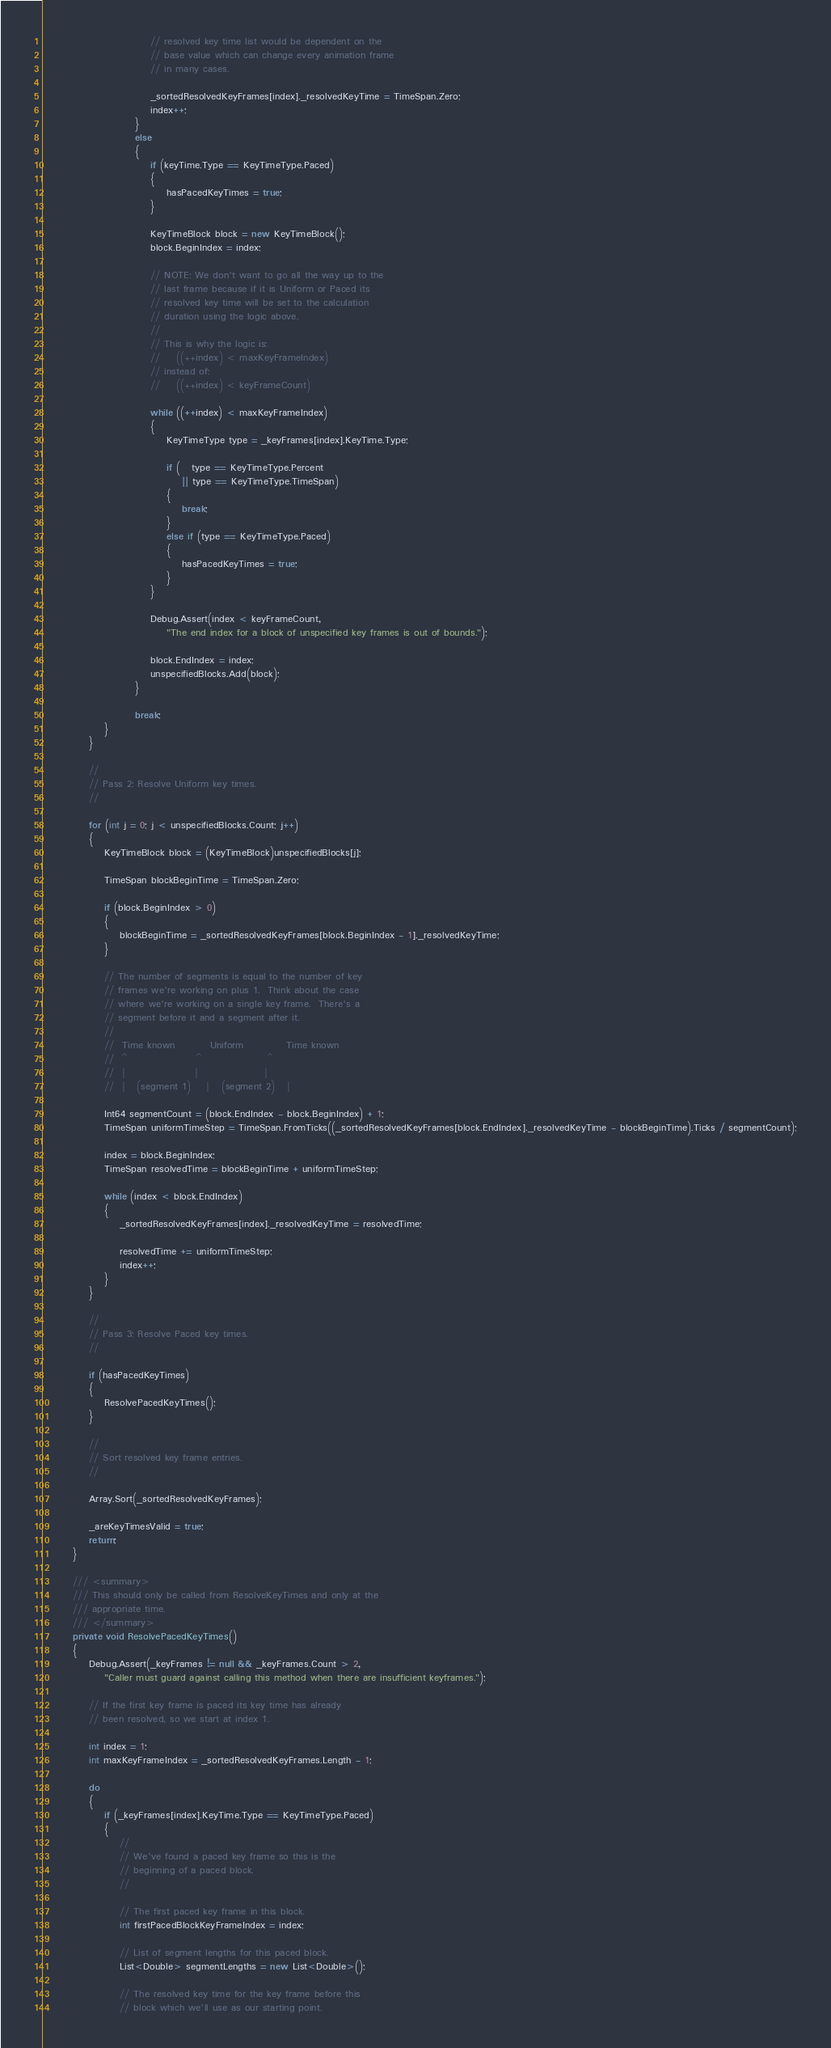Convert code to text. <code><loc_0><loc_0><loc_500><loc_500><_C#_>                            // resolved key time list would be dependent on the
                            // base value which can change every animation frame
                            // in many cases.

                            _sortedResolvedKeyFrames[index]._resolvedKeyTime = TimeSpan.Zero;
                            index++;
                        }
                        else
                        {
                            if (keyTime.Type == KeyTimeType.Paced)
                            {
                                hasPacedKeyTimes = true;
                            }

                            KeyTimeBlock block = new KeyTimeBlock();
                            block.BeginIndex = index;

                            // NOTE: We don't want to go all the way up to the
                            // last frame because if it is Uniform or Paced its
                            // resolved key time will be set to the calculation 
                            // duration using the logic above.
                            //
                            // This is why the logic is:
                            //    ((++index) < maxKeyFrameIndex)
                            // instead of:
                            //    ((++index) < keyFrameCount)

                            while ((++index) < maxKeyFrameIndex)
                            {
                                KeyTimeType type = _keyFrames[index].KeyTime.Type;

                                if (   type == KeyTimeType.Percent
                                    || type == KeyTimeType.TimeSpan)
                                {
                                    break;
                                }   
                                else if (type == KeyTimeType.Paced)
                                {
                                    hasPacedKeyTimes = true;
                                }                                
                            }

                            Debug.Assert(index < keyFrameCount, 
                                "The end index for a block of unspecified key frames is out of bounds.");

                            block.EndIndex = index;
                            unspecifiedBlocks.Add(block);
                        }

                        break;
                }
            }

            //
            // Pass 2: Resolve Uniform key times.
            //

            for (int j = 0; j < unspecifiedBlocks.Count; j++)
            {
                KeyTimeBlock block = (KeyTimeBlock)unspecifiedBlocks[j];

                TimeSpan blockBeginTime = TimeSpan.Zero;

                if (block.BeginIndex > 0)
                {
                    blockBeginTime = _sortedResolvedKeyFrames[block.BeginIndex - 1]._resolvedKeyTime;
                }

                // The number of segments is equal to the number of key
                // frames we're working on plus 1.  Think about the case
                // where we're working on a single key frame.  There's a
                // segment before it and a segment after it.
                //
                //  Time known         Uniform           Time known
                //  ^                  ^                 ^
                //  |                  |                 |
                //  |   (segment 1)    |   (segment 2)   |

                Int64 segmentCount = (block.EndIndex - block.BeginIndex) + 1;
                TimeSpan uniformTimeStep = TimeSpan.FromTicks((_sortedResolvedKeyFrames[block.EndIndex]._resolvedKeyTime - blockBeginTime).Ticks / segmentCount);

                index = block.BeginIndex;
                TimeSpan resolvedTime = blockBeginTime + uniformTimeStep;

                while (index < block.EndIndex)
                {
                    _sortedResolvedKeyFrames[index]._resolvedKeyTime = resolvedTime;

                    resolvedTime += uniformTimeStep;
                    index++;
                }
            }

            //
            // Pass 3: Resolve Paced key times.
            //

            if (hasPacedKeyTimes)
            {
                ResolvePacedKeyTimes();
            }

            //
            // Sort resolved key frame entries.
            //

            Array.Sort(_sortedResolvedKeyFrames);

            _areKeyTimesValid = true;
            return;
        }

        /// <summary>
        /// This should only be called from ResolveKeyTimes and only at the
        /// appropriate time.
        /// </summary>
        private void ResolvePacedKeyTimes()
        {
            Debug.Assert(_keyFrames != null && _keyFrames.Count > 2,
                "Caller must guard against calling this method when there are insufficient keyframes.");

            // If the first key frame is paced its key time has already
            // been resolved, so we start at index 1.

            int index = 1;
            int maxKeyFrameIndex = _sortedResolvedKeyFrames.Length - 1;

            do
            {
                if (_keyFrames[index].KeyTime.Type == KeyTimeType.Paced)
                {
                    //
                    // We've found a paced key frame so this is the
                    // beginning of a paced block.
                    //

                    // The first paced key frame in this block.
                    int firstPacedBlockKeyFrameIndex = index;

                    // List of segment lengths for this paced block.
                    List<Double> segmentLengths = new List<Double>();

                    // The resolved key time for the key frame before this
                    // block which we'll use as our starting point.</code> 